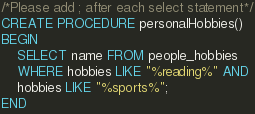<code> <loc_0><loc_0><loc_500><loc_500><_SQL_>/*Please add ; after each select statement*/
CREATE PROCEDURE personalHobbies()
BEGIN
	SELECT name FROM people_hobbies
    WHERE hobbies LIKE "%reading%" AND
    hobbies LIKE "%sports%";
END</code> 